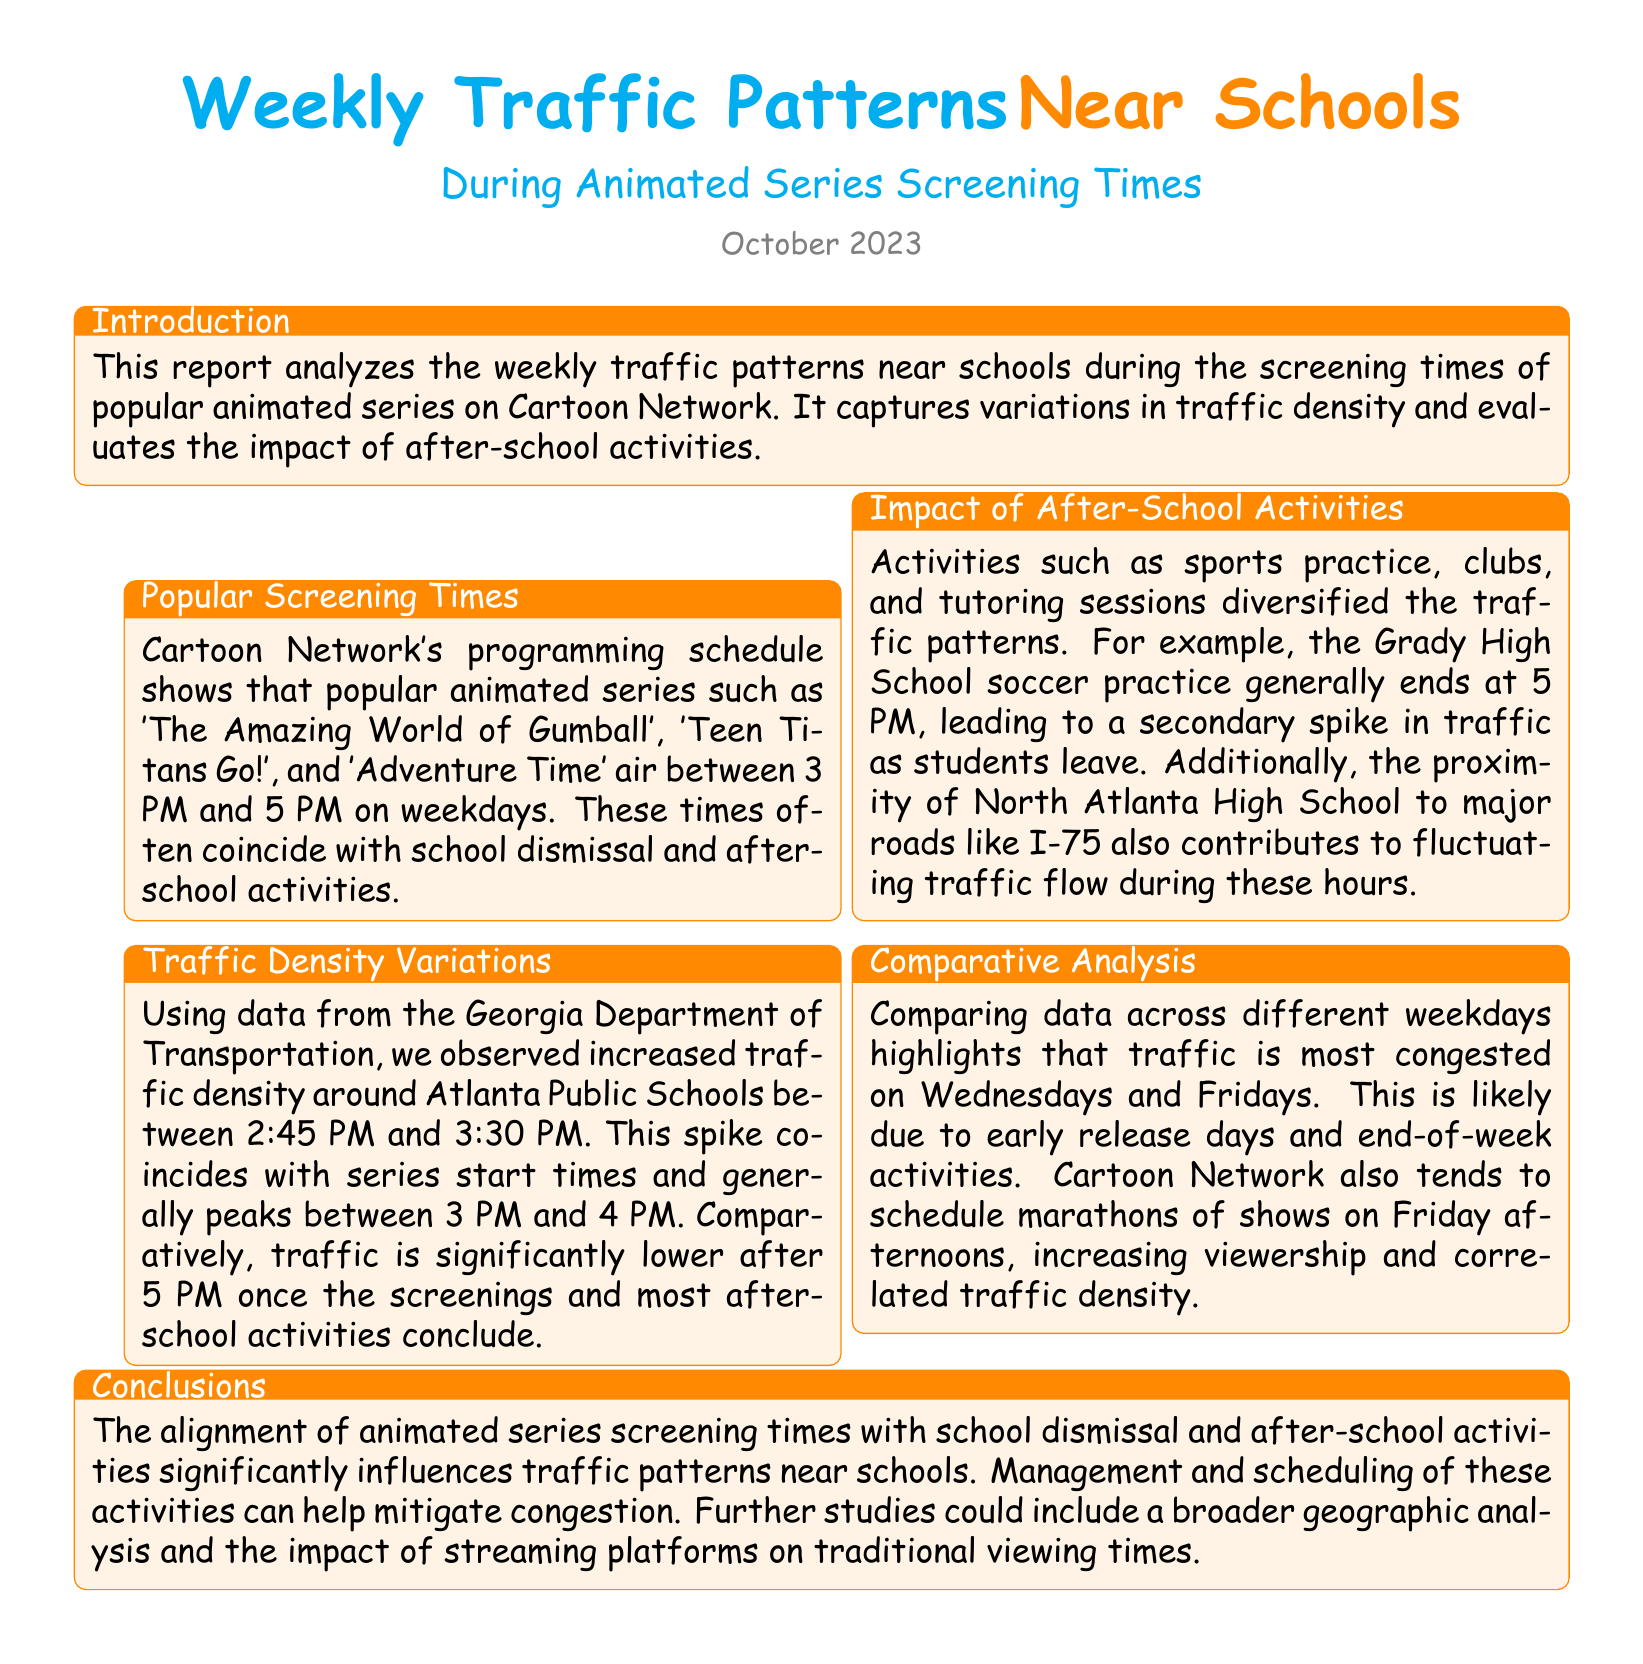What is the primary focus of the report? The report analyzes weekly traffic patterns near schools during animated series screening times and evaluates the impact of after-school activities.
Answer: Traffic patterns near schools What are the popular animated series mentioned? The document lists specific shows that are relevant to the traffic analysis.
Answer: The Amazing World of Gumball, Teen Titans Go!, Adventure Time What time period did the traffic spike occur? The traffic spike is indicated in the document, highlighting peak hours.
Answer: Between 2:45 PM and 3:30 PM Which day of the week is traffic most congested? The report discusses variations in traffic density across weekdays.
Answer: Wednesdays and Fridays What is the time frame for the animated series screenings? The report specifies when the screenings of animated series take place.
Answer: Between 3 PM and 5 PM What contributes to the secondary spike in traffic? The document highlights specific factors that influence changes in traffic density.
Answer: Grady High School soccer practice What was observed after 5 PM? The report mentions changes in traffic patterns after certain events conclude.
Answer: Significantly lower traffic What is a potential area for further studies mentioned? The conclusion of the report suggests additional research areas for the future.
Answer: Broader geographic analysis What factor increases viewership and correlates with traffic density? The report provides insights into factors influencing both traffic and viewer engagement.
Answer: Marathons of shows on Friday afternoons 